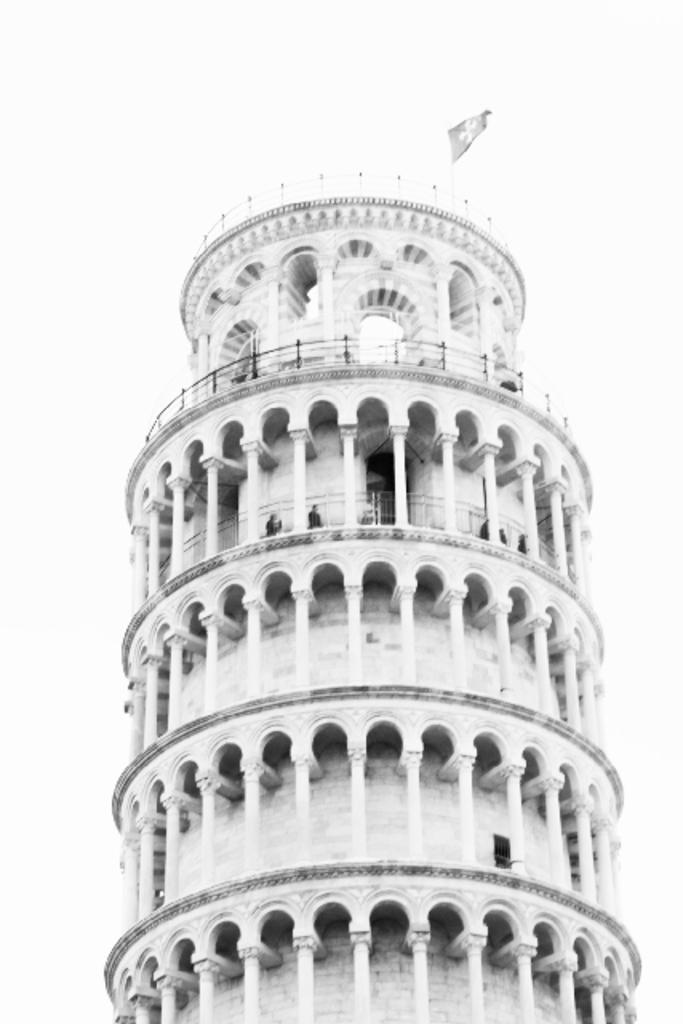What is the main structure in the center of the image? There is a tower in the center of the image. What is at the top of the tower? There is a flag at the top of the tower. How many snakes are wrapped around the tower in the image? There are no snakes present in the image; the tower has a flag at the top. 